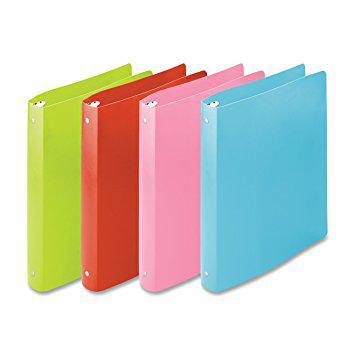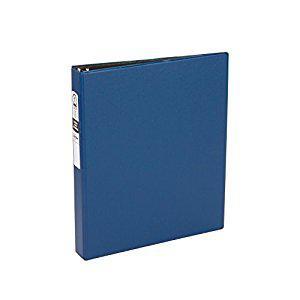The first image is the image on the left, the second image is the image on the right. Evaluate the accuracy of this statement regarding the images: "Five note books, all in different colors, are shown, four in one image all facing the same way, and one in the other image that has a white label on the spine.". Is it true? Answer yes or no. Yes. The first image is the image on the left, the second image is the image on the right. Given the left and right images, does the statement "One image shows four upright binders of different colors, and the other shows just one upright binder." hold true? Answer yes or no. Yes. 